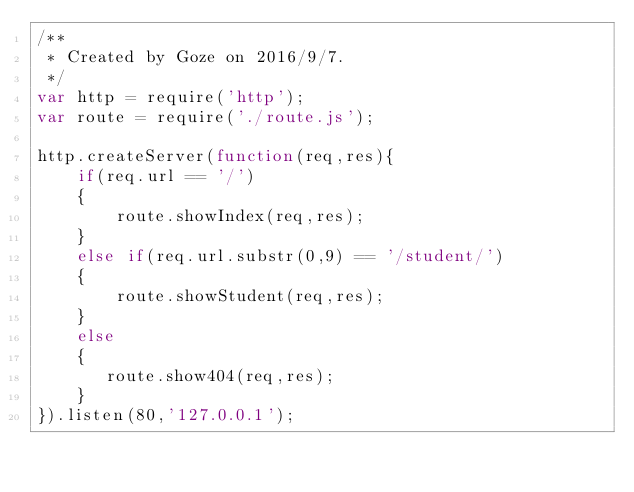Convert code to text. <code><loc_0><loc_0><loc_500><loc_500><_JavaScript_>/**
 * Created by Goze on 2016/9/7.
 */
var http = require('http');
var route = require('./route.js');

http.createServer(function(req,res){
    if(req.url == '/')
    {
        route.showIndex(req,res);
    }
    else if(req.url.substr(0,9) == '/student/')
    {
        route.showStudent(req,res);
    }
    else
    {
       route.show404(req,res);
    }
}).listen(80,'127.0.0.1');</code> 